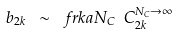Convert formula to latex. <formula><loc_0><loc_0><loc_500><loc_500>b _ { 2 k } \ \sim \ f r { k a } { N _ { C } } \ C _ { 2 k } ^ { N _ { C } \rightarrow \infty }</formula> 